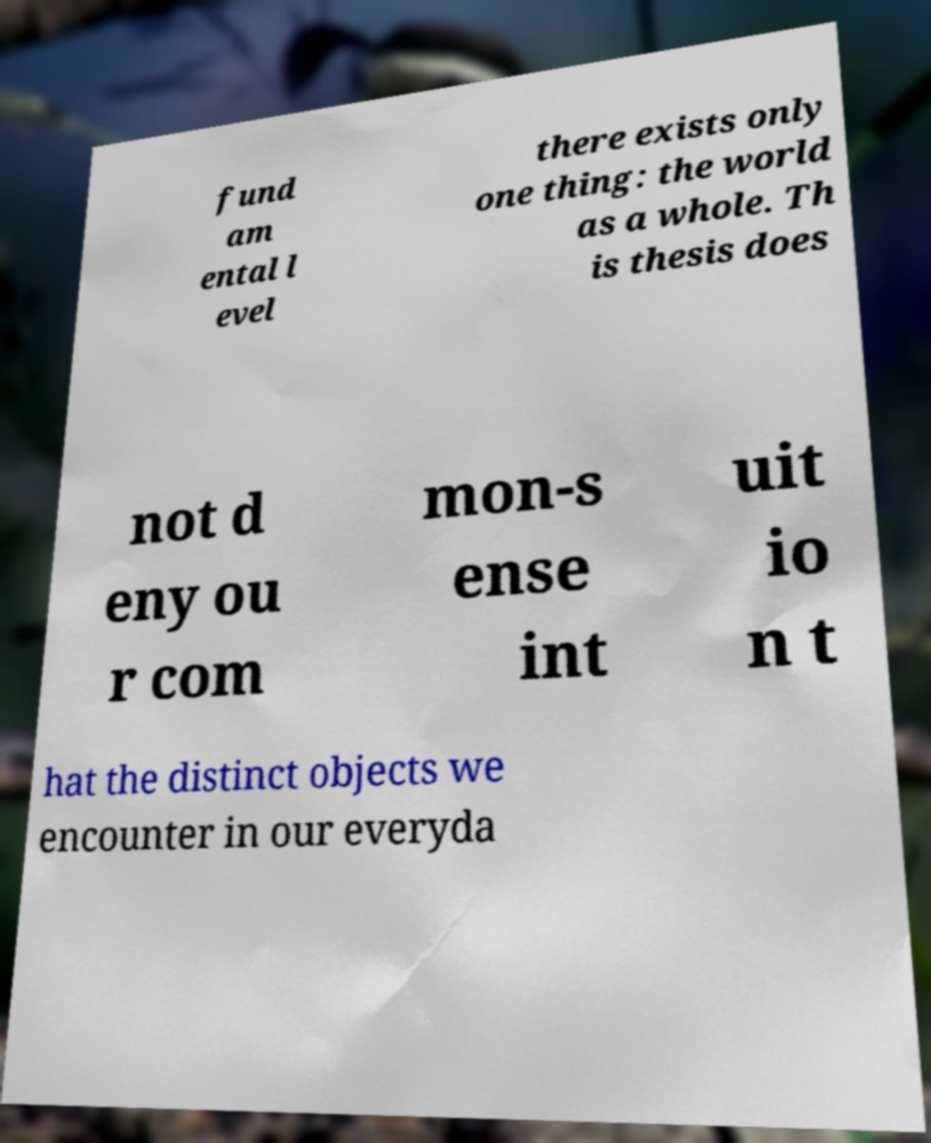Could you assist in decoding the text presented in this image and type it out clearly? fund am ental l evel there exists only one thing: the world as a whole. Th is thesis does not d eny ou r com mon-s ense int uit io n t hat the distinct objects we encounter in our everyda 